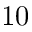Convert formula to latex. <formula><loc_0><loc_0><loc_500><loc_500>1 0</formula> 